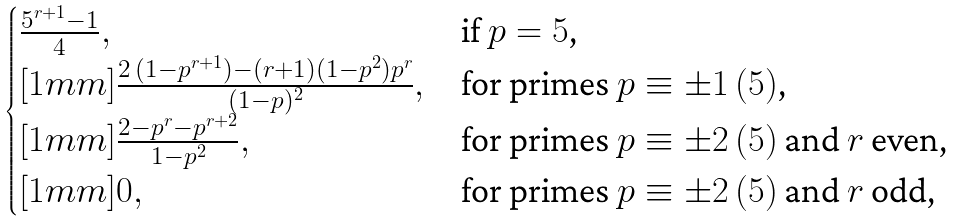Convert formula to latex. <formula><loc_0><loc_0><loc_500><loc_500>\begin{cases} \frac { 5 ^ { r + 1 } - 1 } { 4 } , & \text {if $p=5$,} \\ [ 1 m m ] \frac { 2 \, ( 1 - p ^ { r + 1 } ) - ( r + 1 ) ( 1 - p ^ { 2 } ) p ^ { r } } { ( 1 - p ) ^ { 2 } } , & \text {for primes $p\equiv\pm 1 \, (5)$,} \\ [ 1 m m ] \frac { 2 - p ^ { r } - p ^ { r + 2 } } { 1 - p ^ { 2 } } , & \text {for primes $p\equiv\pm 2 \, (5)$ and $r$ even,} \\ [ 1 m m ] 0 , & \text {for primes $p\equiv\pm 2 \, (5)$ and $r$ odd,} \end{cases}</formula> 